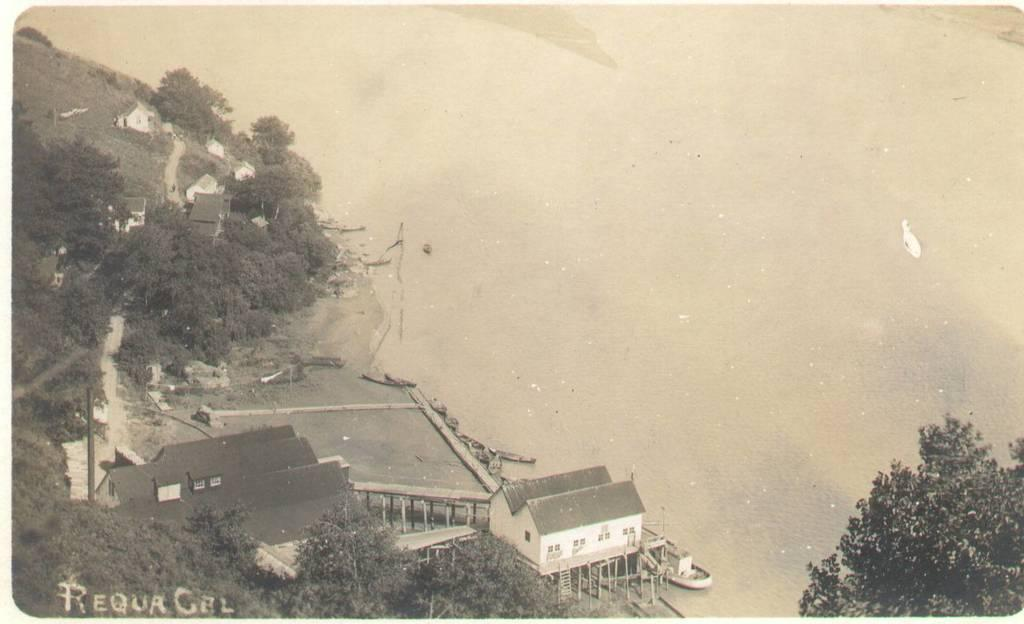What type of structures are visible in the image? There are houses in the image. What other natural elements can be seen in the image? There are trees in the image. What is the water-related feature in the image? There are boats on the water in the image. How is the image presented in terms of color? The image is black and white in color. Is there any additional marking on the image? Yes, there is a watermark on the image. Can you see any clams in the water near the boats? There are no clams visible in the image; it only shows boats on the water. Are there any dolls hanging from the trees in the image? There are no dolls present in the image; it features houses, trees, boats, and water. 